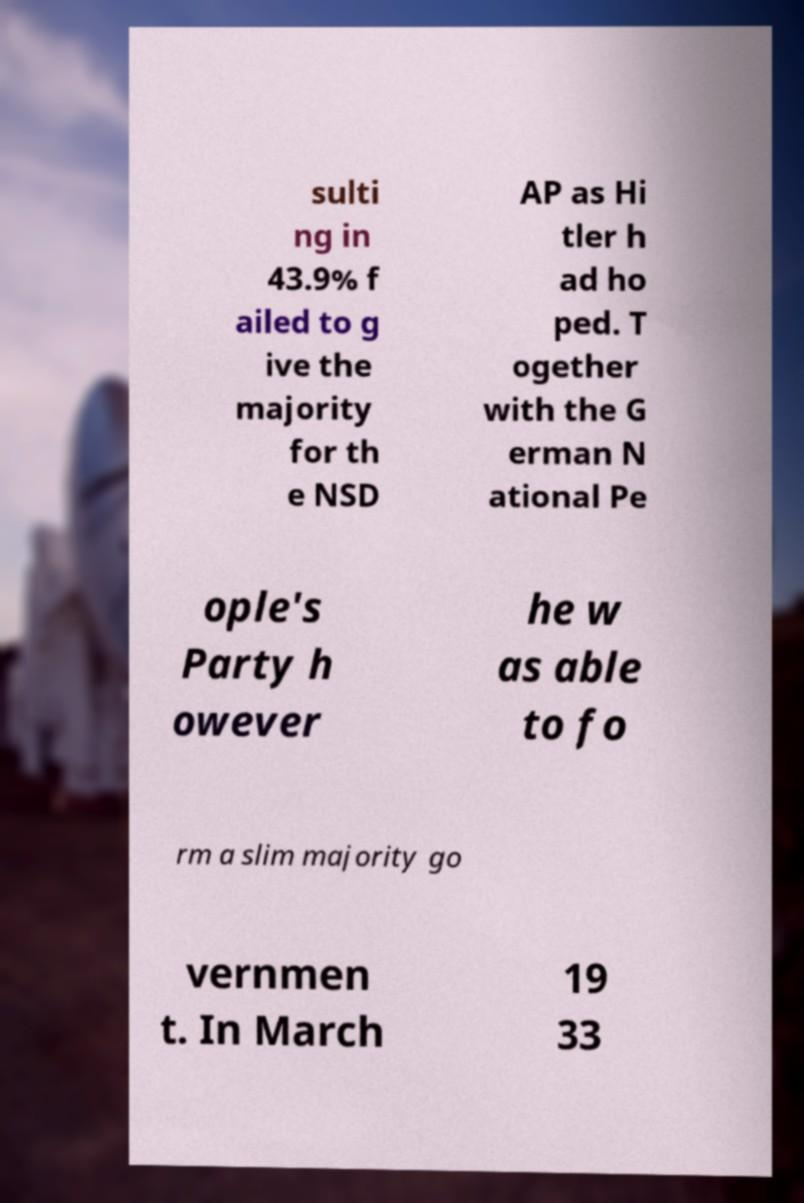I need the written content from this picture converted into text. Can you do that? sulti ng in 43.9% f ailed to g ive the majority for th e NSD AP as Hi tler h ad ho ped. T ogether with the G erman N ational Pe ople's Party h owever he w as able to fo rm a slim majority go vernmen t. In March 19 33 